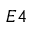Convert formula to latex. <formula><loc_0><loc_0><loc_500><loc_500>E 4</formula> 